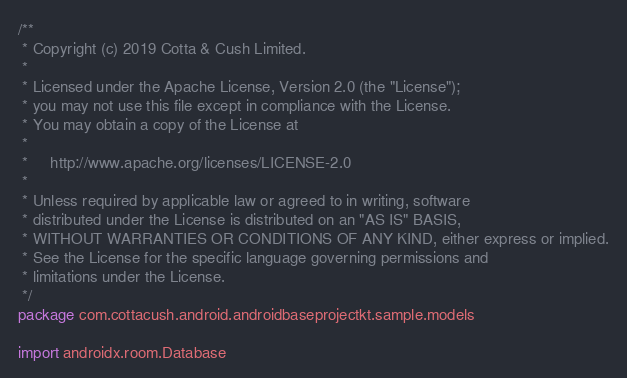<code> <loc_0><loc_0><loc_500><loc_500><_Kotlin_>/**
 * Copyright (c) 2019 Cotta & Cush Limited.
 *
 * Licensed under the Apache License, Version 2.0 (the "License");
 * you may not use this file except in compliance with the License.
 * You may obtain a copy of the License at
 *
 *     http://www.apache.org/licenses/LICENSE-2.0
 *
 * Unless required by applicable law or agreed to in writing, software
 * distributed under the License is distributed on an "AS IS" BASIS,
 * WITHOUT WARRANTIES OR CONDITIONS OF ANY KIND, either express or implied.
 * See the License for the specific language governing permissions and
 * limitations under the License.
 */
package com.cottacush.android.androidbaseprojectkt.sample.models

import androidx.room.Database</code> 